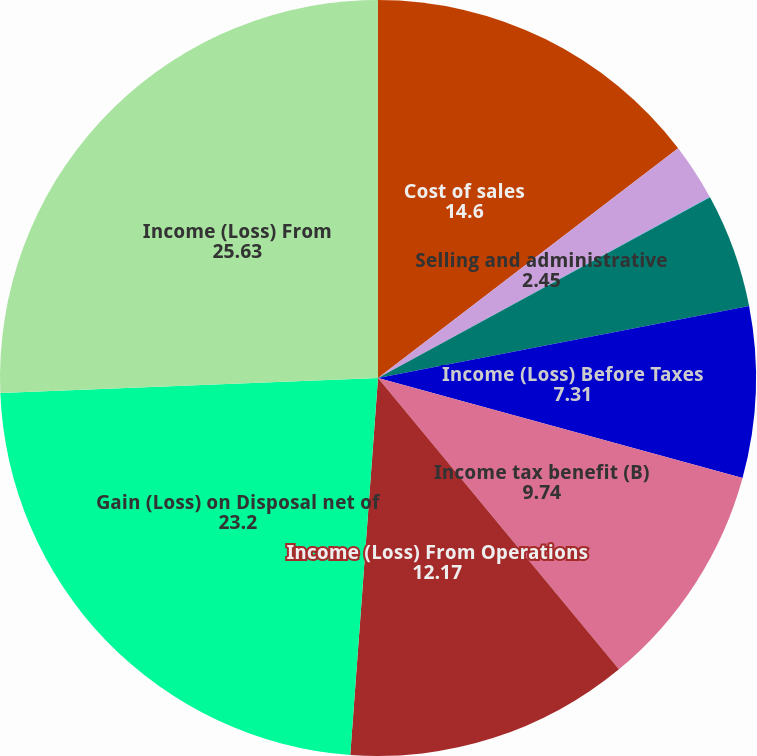<chart> <loc_0><loc_0><loc_500><loc_500><pie_chart><fcel>Cost of sales<fcel>Selling and administrative<fcel>Other income (expense) net<fcel>Operating Income (Loss)<fcel>Income (Loss) Before Taxes<fcel>Income tax benefit (B)<fcel>Income (Loss) From Operations<fcel>Gain (Loss) on Disposal net of<fcel>Income (Loss) From<nl><fcel>14.6%<fcel>2.45%<fcel>0.02%<fcel>4.88%<fcel>7.31%<fcel>9.74%<fcel>12.17%<fcel>23.2%<fcel>25.63%<nl></chart> 